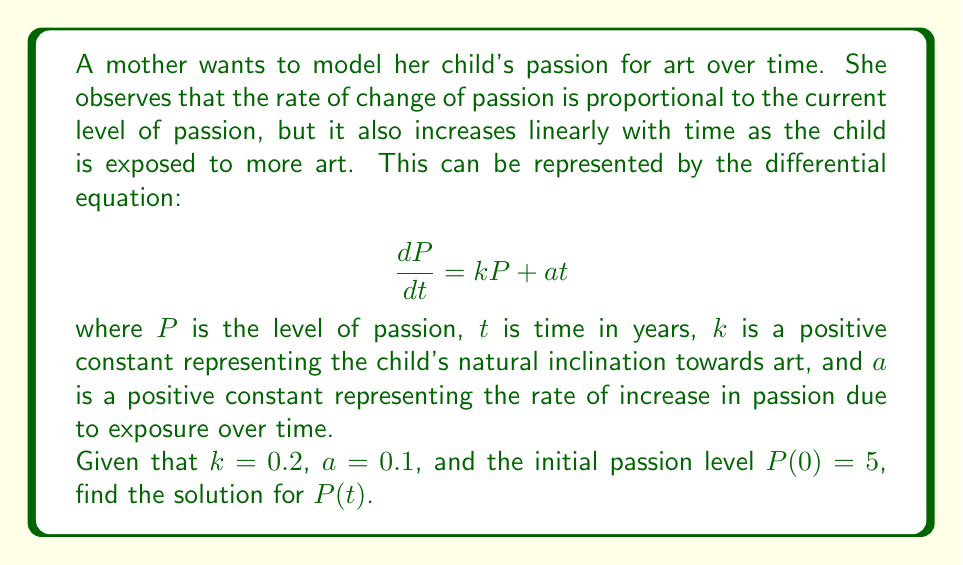Can you solve this math problem? To solve this differential equation, we can use the method of integrating factors:

1) First, rewrite the equation in standard form:
   $$\frac{dP}{dt} - kP = at$$

2) The integrating factor is $\mu(t) = e^{-\int k dt} = e^{-kt}$

3) Multiply both sides of the equation by the integrating factor:
   $$e^{-kt}\frac{dP}{dt} - ke^{-kt}P = ate^{-kt}$$

4) The left side is now the derivative of $e^{-kt}P$:
   $$\frac{d}{dt}(e^{-kt}P) = ate^{-kt}$$

5) Integrate both sides:
   $$e^{-kt}P = \int ate^{-kt} dt$$

6) Solve the integral on the right side using integration by parts:
   $$\int ate^{-kt} dt = -\frac{at}{k}e^{-kt} + \frac{a}{k^2}e^{-kt} + C$$

7) Substitute back:
   $$e^{-kt}P = -\frac{at}{k}e^{-kt} + \frac{a}{k^2}e^{-kt} + C$$

8) Multiply both sides by $e^{kt}$:
   $$P = -\frac{at}{k} + \frac{a}{k^2} + Ce^{kt}$$

9) Use the initial condition $P(0) = 5$ to find $C$:
   $$5 = \frac{a}{k^2} + C$$
   $$C = 5 - \frac{a}{k^2} = 5 - \frac{0.1}{0.2^2} = 2.5$$

10) The final solution is:
    $$P(t) = -\frac{at}{k} + \frac{a}{k^2} + (5 - \frac{a}{k^2})e^{kt}$$

11) Substitute the values of $k$ and $a$:
    $$P(t) = -0.5t + 2.5 + 2.5e^{0.2t}$$
Answer: $$P(t) = -0.5t + 2.5 + 2.5e^{0.2t}$$ 